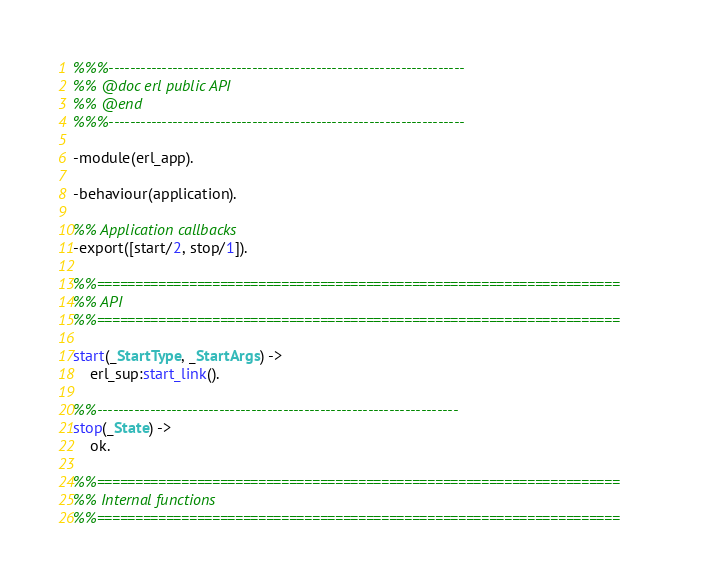Convert code to text. <code><loc_0><loc_0><loc_500><loc_500><_Erlang_>%%%-------------------------------------------------------------------
%% @doc erl public API
%% @end
%%%-------------------------------------------------------------------

-module(erl_app).

-behaviour(application).

%% Application callbacks
-export([start/2, stop/1]).

%%====================================================================
%% API
%%====================================================================

start(_StartType, _StartArgs) ->
    erl_sup:start_link().

%%--------------------------------------------------------------------
stop(_State) ->
    ok.

%%====================================================================
%% Internal functions
%%====================================================================
</code> 